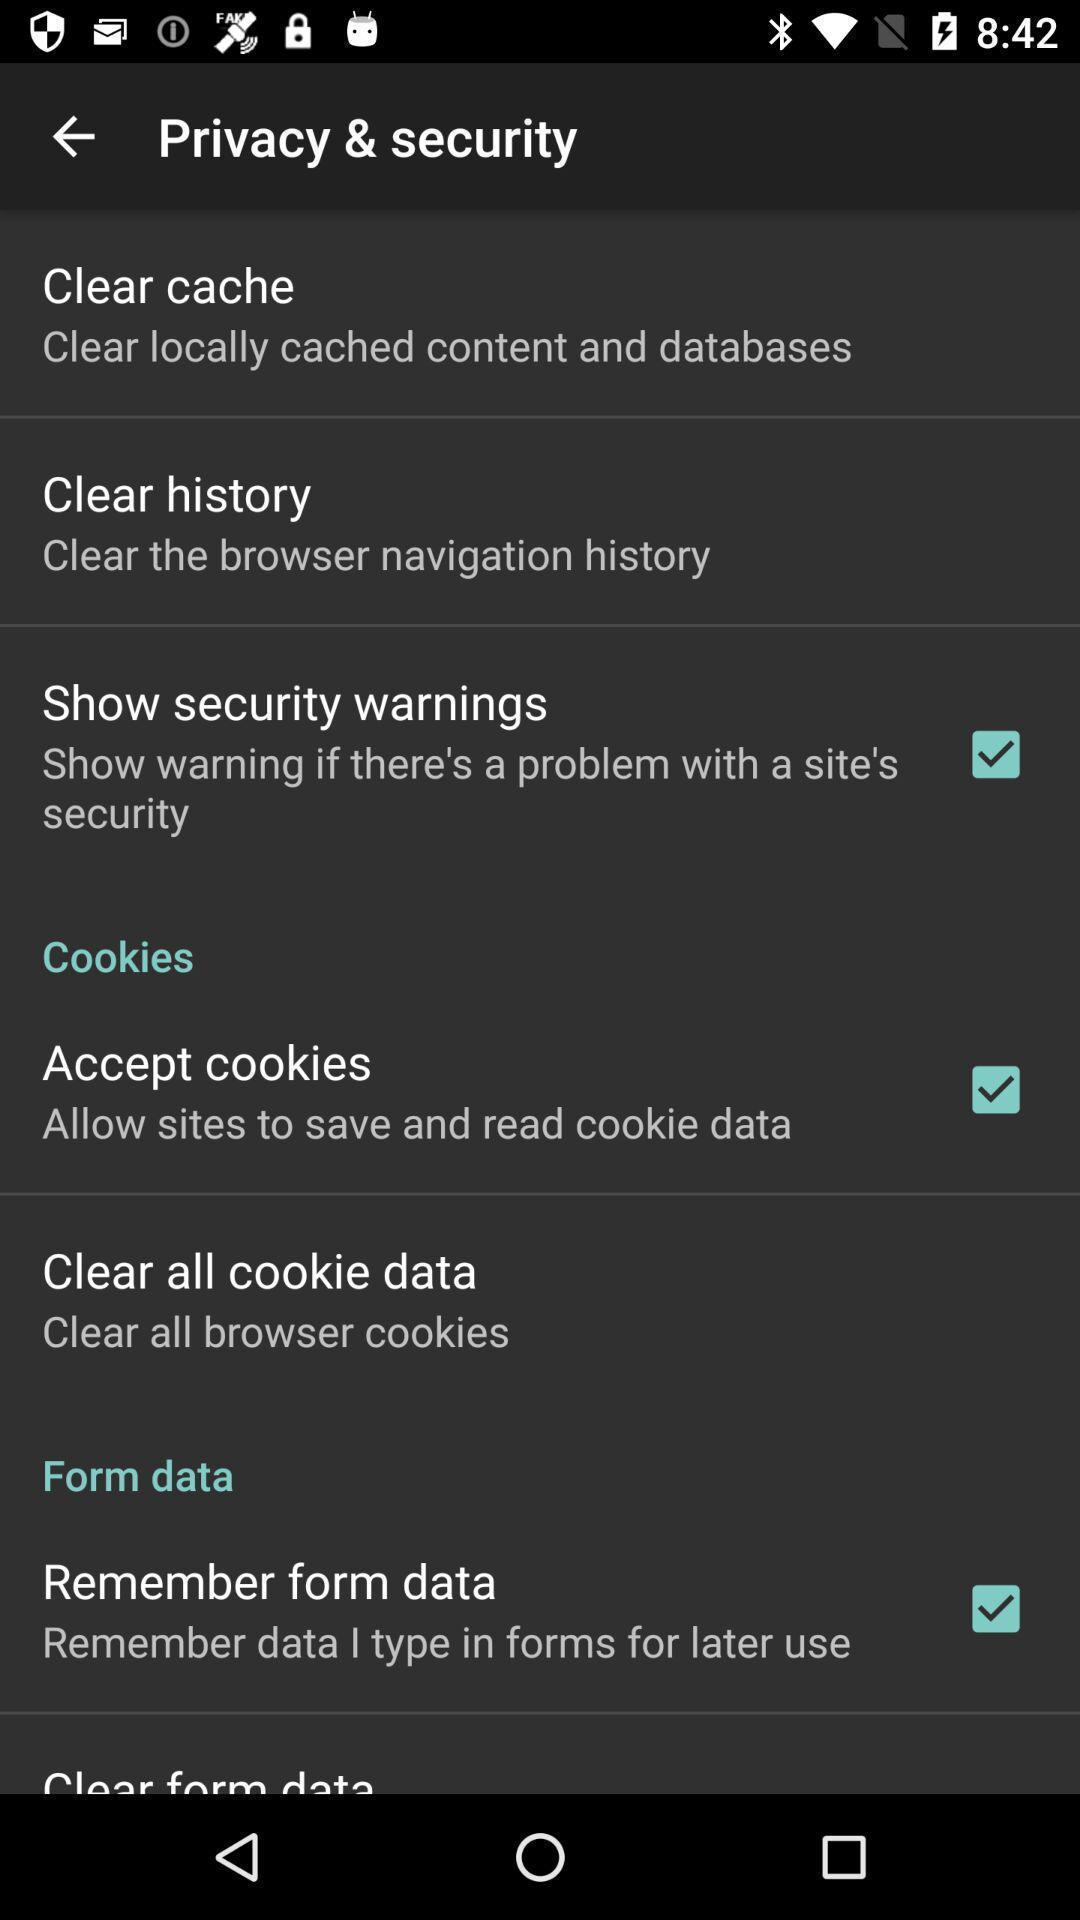Summarize the main components in this picture. Screen shows privacy security details. 